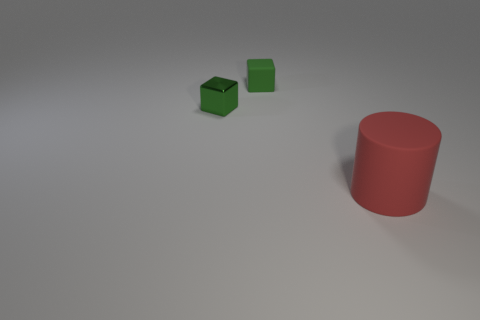The small thing that is in front of the matte object that is behind the large matte cylinder is what color?
Your response must be concise. Green. What is the shape of the big object?
Make the answer very short. Cylinder. There is a matte thing behind the cylinder; is it the same size as the small metal block?
Make the answer very short. Yes. Is there a large gray cube made of the same material as the large cylinder?
Your answer should be compact. No. How many objects are rubber things left of the big rubber thing or big matte objects?
Provide a succinct answer. 2. Are there any tiny purple matte cylinders?
Provide a succinct answer. No. There is a object that is both behind the large red rubber cylinder and right of the tiny green metallic block; what shape is it?
Ensure brevity in your answer.  Cube. There is a matte object on the left side of the large red object; what size is it?
Give a very brief answer. Small. Does the matte thing on the left side of the cylinder have the same color as the metallic cube?
Your answer should be compact. Yes. What number of green metal things are the same shape as the large matte object?
Ensure brevity in your answer.  0. 